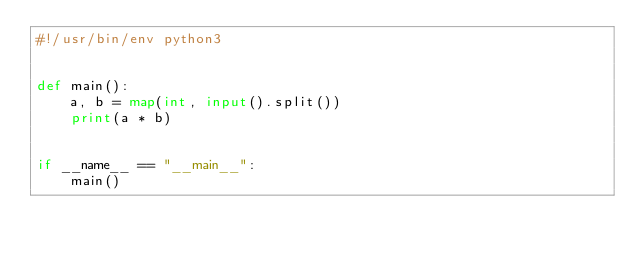<code> <loc_0><loc_0><loc_500><loc_500><_Python_>#!/usr/bin/env python3


def main():
    a, b = map(int, input().split())
    print(a * b)


if __name__ == "__main__":
    main()
</code> 